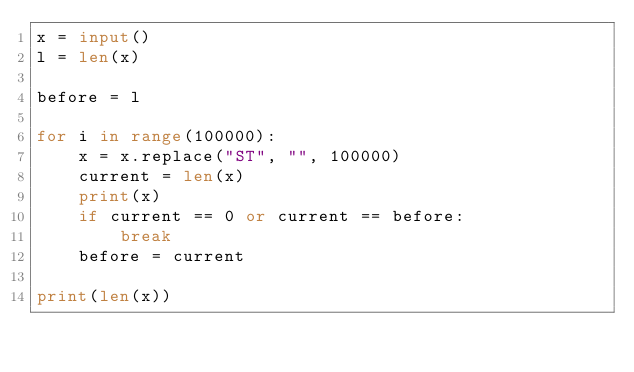Convert code to text. <code><loc_0><loc_0><loc_500><loc_500><_Python_>x = input()
l = len(x)

before = l

for i in range(100000):
    x = x.replace("ST", "", 100000)
    current = len(x)
    print(x)
    if current == 0 or current == before:
        break
    before = current

print(len(x))
</code> 